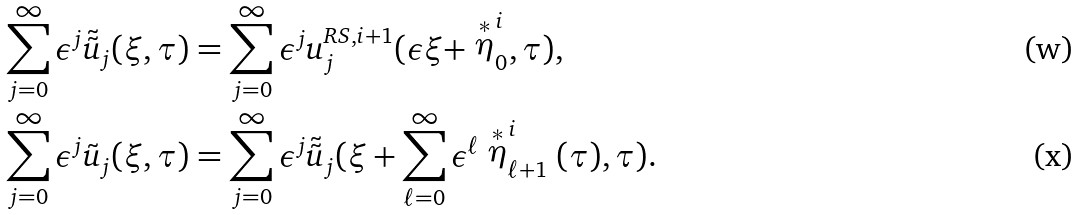Convert formula to latex. <formula><loc_0><loc_0><loc_500><loc_500>\sum ^ { \infty } _ { j = 0 } \epsilon ^ { j } \tilde { \tilde { u } } _ { j } ( \xi , \tau ) & = \sum ^ { \infty } _ { j = 0 } \epsilon ^ { j } u ^ { R S , i + 1 } _ { j } ( \epsilon \xi + \stackrel { * } { \eta } ^ { i } _ { 0 } , \tau ) , \\ \sum ^ { \infty } _ { j = 0 } \epsilon ^ { j } \tilde { u } _ { j } ( \xi , \tau ) & = \sum ^ { \infty } _ { j = 0 } \epsilon ^ { j } \tilde { \tilde { u } } _ { j } ( \xi + \sum ^ { \infty } _ { \ell = 0 } \epsilon ^ { \ell } \stackrel { * } { \eta } ^ { i } _ { \ell + 1 } ( \tau ) , \tau ) .</formula> 